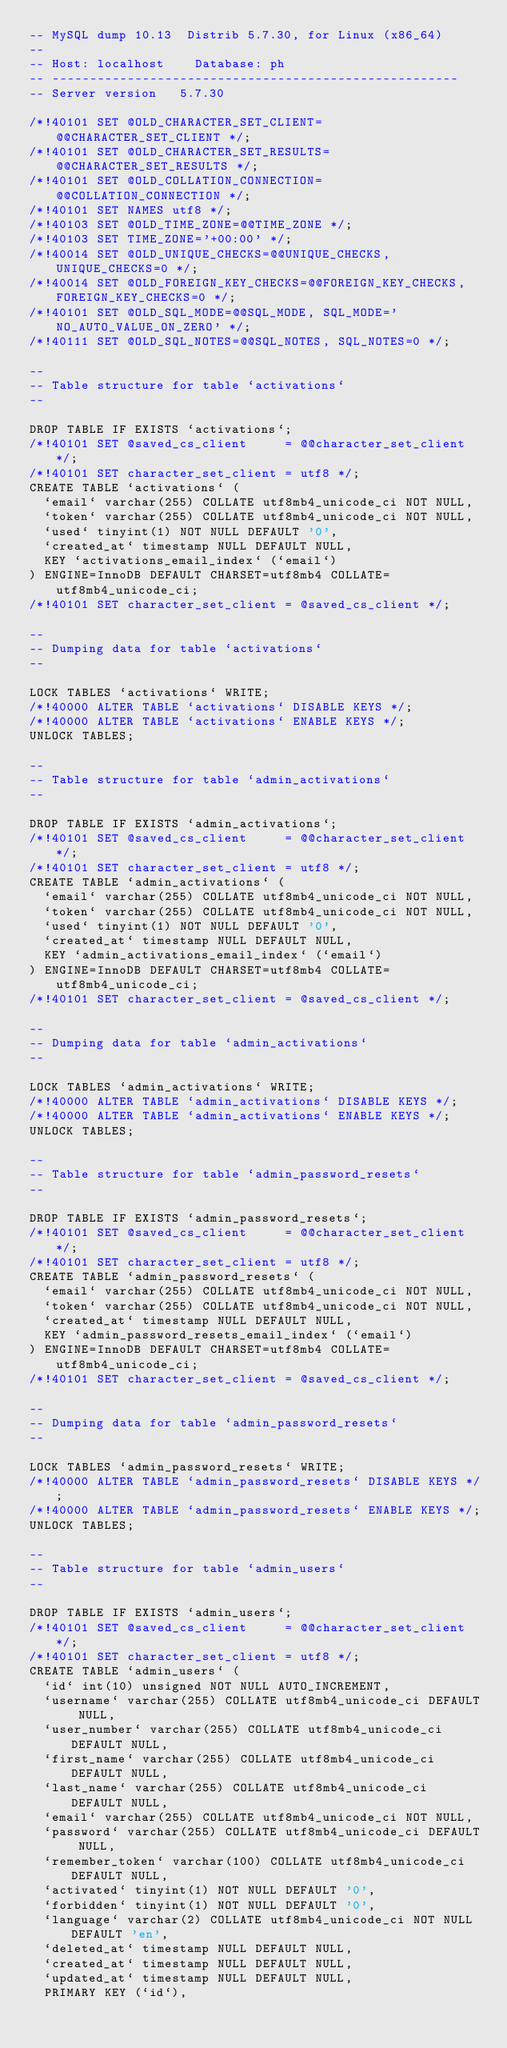<code> <loc_0><loc_0><loc_500><loc_500><_SQL_>-- MySQL dump 10.13  Distrib 5.7.30, for Linux (x86_64)
--
-- Host: localhost    Database: ph
-- ------------------------------------------------------
-- Server version	5.7.30

/*!40101 SET @OLD_CHARACTER_SET_CLIENT=@@CHARACTER_SET_CLIENT */;
/*!40101 SET @OLD_CHARACTER_SET_RESULTS=@@CHARACTER_SET_RESULTS */;
/*!40101 SET @OLD_COLLATION_CONNECTION=@@COLLATION_CONNECTION */;
/*!40101 SET NAMES utf8 */;
/*!40103 SET @OLD_TIME_ZONE=@@TIME_ZONE */;
/*!40103 SET TIME_ZONE='+00:00' */;
/*!40014 SET @OLD_UNIQUE_CHECKS=@@UNIQUE_CHECKS, UNIQUE_CHECKS=0 */;
/*!40014 SET @OLD_FOREIGN_KEY_CHECKS=@@FOREIGN_KEY_CHECKS, FOREIGN_KEY_CHECKS=0 */;
/*!40101 SET @OLD_SQL_MODE=@@SQL_MODE, SQL_MODE='NO_AUTO_VALUE_ON_ZERO' */;
/*!40111 SET @OLD_SQL_NOTES=@@SQL_NOTES, SQL_NOTES=0 */;

--
-- Table structure for table `activations`
--

DROP TABLE IF EXISTS `activations`;
/*!40101 SET @saved_cs_client     = @@character_set_client */;
/*!40101 SET character_set_client = utf8 */;
CREATE TABLE `activations` (
  `email` varchar(255) COLLATE utf8mb4_unicode_ci NOT NULL,
  `token` varchar(255) COLLATE utf8mb4_unicode_ci NOT NULL,
  `used` tinyint(1) NOT NULL DEFAULT '0',
  `created_at` timestamp NULL DEFAULT NULL,
  KEY `activations_email_index` (`email`)
) ENGINE=InnoDB DEFAULT CHARSET=utf8mb4 COLLATE=utf8mb4_unicode_ci;
/*!40101 SET character_set_client = @saved_cs_client */;

--
-- Dumping data for table `activations`
--

LOCK TABLES `activations` WRITE;
/*!40000 ALTER TABLE `activations` DISABLE KEYS */;
/*!40000 ALTER TABLE `activations` ENABLE KEYS */;
UNLOCK TABLES;

--
-- Table structure for table `admin_activations`
--

DROP TABLE IF EXISTS `admin_activations`;
/*!40101 SET @saved_cs_client     = @@character_set_client */;
/*!40101 SET character_set_client = utf8 */;
CREATE TABLE `admin_activations` (
  `email` varchar(255) COLLATE utf8mb4_unicode_ci NOT NULL,
  `token` varchar(255) COLLATE utf8mb4_unicode_ci NOT NULL,
  `used` tinyint(1) NOT NULL DEFAULT '0',
  `created_at` timestamp NULL DEFAULT NULL,
  KEY `admin_activations_email_index` (`email`)
) ENGINE=InnoDB DEFAULT CHARSET=utf8mb4 COLLATE=utf8mb4_unicode_ci;
/*!40101 SET character_set_client = @saved_cs_client */;

--
-- Dumping data for table `admin_activations`
--

LOCK TABLES `admin_activations` WRITE;
/*!40000 ALTER TABLE `admin_activations` DISABLE KEYS */;
/*!40000 ALTER TABLE `admin_activations` ENABLE KEYS */;
UNLOCK TABLES;

--
-- Table structure for table `admin_password_resets`
--

DROP TABLE IF EXISTS `admin_password_resets`;
/*!40101 SET @saved_cs_client     = @@character_set_client */;
/*!40101 SET character_set_client = utf8 */;
CREATE TABLE `admin_password_resets` (
  `email` varchar(255) COLLATE utf8mb4_unicode_ci NOT NULL,
  `token` varchar(255) COLLATE utf8mb4_unicode_ci NOT NULL,
  `created_at` timestamp NULL DEFAULT NULL,
  KEY `admin_password_resets_email_index` (`email`)
) ENGINE=InnoDB DEFAULT CHARSET=utf8mb4 COLLATE=utf8mb4_unicode_ci;
/*!40101 SET character_set_client = @saved_cs_client */;

--
-- Dumping data for table `admin_password_resets`
--

LOCK TABLES `admin_password_resets` WRITE;
/*!40000 ALTER TABLE `admin_password_resets` DISABLE KEYS */;
/*!40000 ALTER TABLE `admin_password_resets` ENABLE KEYS */;
UNLOCK TABLES;

--
-- Table structure for table `admin_users`
--

DROP TABLE IF EXISTS `admin_users`;
/*!40101 SET @saved_cs_client     = @@character_set_client */;
/*!40101 SET character_set_client = utf8 */;
CREATE TABLE `admin_users` (
  `id` int(10) unsigned NOT NULL AUTO_INCREMENT,
  `username` varchar(255) COLLATE utf8mb4_unicode_ci DEFAULT NULL,
  `user_number` varchar(255) COLLATE utf8mb4_unicode_ci DEFAULT NULL,
  `first_name` varchar(255) COLLATE utf8mb4_unicode_ci DEFAULT NULL,
  `last_name` varchar(255) COLLATE utf8mb4_unicode_ci DEFAULT NULL,
  `email` varchar(255) COLLATE utf8mb4_unicode_ci NOT NULL,
  `password` varchar(255) COLLATE utf8mb4_unicode_ci DEFAULT NULL,
  `remember_token` varchar(100) COLLATE utf8mb4_unicode_ci DEFAULT NULL,
  `activated` tinyint(1) NOT NULL DEFAULT '0',
  `forbidden` tinyint(1) NOT NULL DEFAULT '0',
  `language` varchar(2) COLLATE utf8mb4_unicode_ci NOT NULL DEFAULT 'en',
  `deleted_at` timestamp NULL DEFAULT NULL,
  `created_at` timestamp NULL DEFAULT NULL,
  `updated_at` timestamp NULL DEFAULT NULL,
  PRIMARY KEY (`id`),</code> 